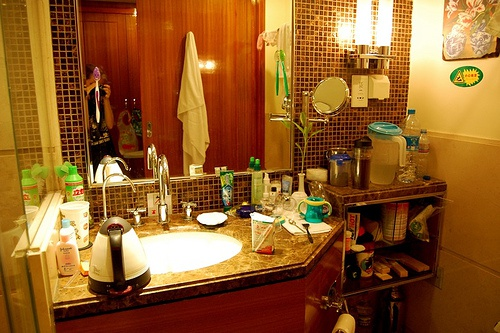Describe the objects in this image and their specific colors. I can see sink in olive, white, khaki, and orange tones, people in olive, black, maroon, and brown tones, bottle in olive, maroon, and orange tones, cup in olive, khaki, lightyellow, and tan tones, and cup in olive, green, and darkgreen tones in this image. 